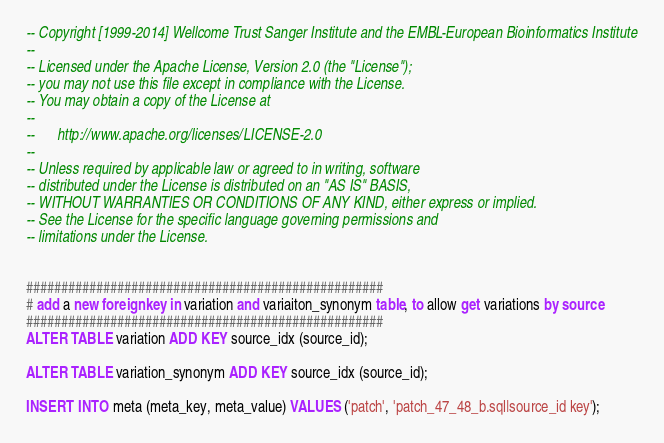<code> <loc_0><loc_0><loc_500><loc_500><_SQL_>-- Copyright [1999-2014] Wellcome Trust Sanger Institute and the EMBL-European Bioinformatics Institute
-- 
-- Licensed under the Apache License, Version 2.0 (the "License");
-- you may not use this file except in compliance with the License.
-- You may obtain a copy of the License at
-- 
--      http://www.apache.org/licenses/LICENSE-2.0
-- 
-- Unless required by applicable law or agreed to in writing, software
-- distributed under the License is distributed on an "AS IS" BASIS,
-- WITHOUT WARRANTIES OR CONDITIONS OF ANY KIND, either express or implied.
-- See the License for the specific language governing permissions and
-- limitations under the License.


###################################################
# add a new foreign key in variation and variaiton_synonym table, to allow get variations by source
###################################################
ALTER TABLE variation ADD KEY source_idx (source_id);

ALTER TABLE variation_synonym ADD KEY source_idx (source_id);

INSERT INTO meta (meta_key, meta_value) VALUES ('patch', 'patch_47_48_b.sql|source_id key');
</code> 